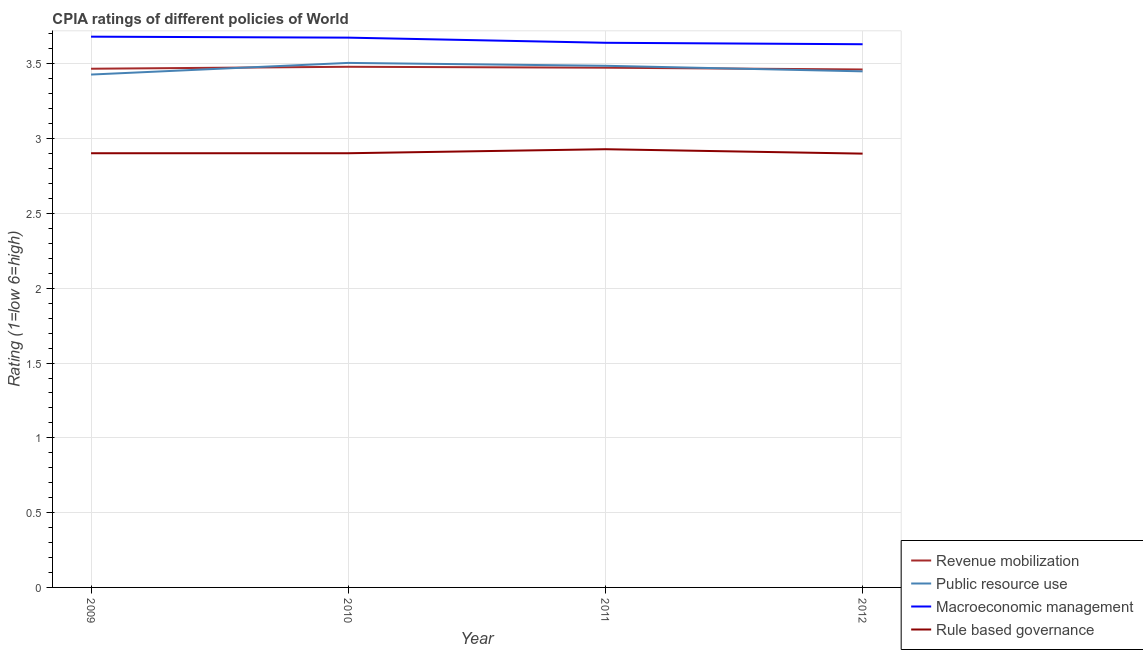How many different coloured lines are there?
Ensure brevity in your answer.  4. Does the line corresponding to cpia rating of rule based governance intersect with the line corresponding to cpia rating of macroeconomic management?
Provide a short and direct response. No. What is the cpia rating of revenue mobilization in 2009?
Your answer should be very brief. 3.47. Across all years, what is the maximum cpia rating of public resource use?
Provide a succinct answer. 3.51. Across all years, what is the minimum cpia rating of rule based governance?
Ensure brevity in your answer.  2.9. In which year was the cpia rating of revenue mobilization maximum?
Provide a succinct answer. 2010. In which year was the cpia rating of public resource use minimum?
Offer a terse response. 2009. What is the total cpia rating of macroeconomic management in the graph?
Offer a very short reply. 14.63. What is the difference between the cpia rating of public resource use in 2009 and that in 2010?
Your answer should be very brief. -0.08. What is the difference between the cpia rating of public resource use in 2011 and the cpia rating of macroeconomic management in 2012?
Your response must be concise. -0.14. What is the average cpia rating of public resource use per year?
Provide a short and direct response. 3.47. In the year 2009, what is the difference between the cpia rating of macroeconomic management and cpia rating of public resource use?
Keep it short and to the point. 0.25. What is the ratio of the cpia rating of macroeconomic management in 2009 to that in 2011?
Make the answer very short. 1.01. Is the difference between the cpia rating of macroeconomic management in 2010 and 2012 greater than the difference between the cpia rating of public resource use in 2010 and 2012?
Your answer should be compact. No. What is the difference between the highest and the second highest cpia rating of rule based governance?
Give a very brief answer. 0.03. What is the difference between the highest and the lowest cpia rating of revenue mobilization?
Provide a succinct answer. 0.02. In how many years, is the cpia rating of rule based governance greater than the average cpia rating of rule based governance taken over all years?
Provide a short and direct response. 1. Is the sum of the cpia rating of macroeconomic management in 2009 and 2012 greater than the maximum cpia rating of rule based governance across all years?
Give a very brief answer. Yes. Is it the case that in every year, the sum of the cpia rating of macroeconomic management and cpia rating of rule based governance is greater than the sum of cpia rating of revenue mobilization and cpia rating of public resource use?
Your answer should be compact. No. Does the cpia rating of public resource use monotonically increase over the years?
Your answer should be compact. No. Are the values on the major ticks of Y-axis written in scientific E-notation?
Your answer should be very brief. No. Does the graph contain any zero values?
Your answer should be compact. No. Where does the legend appear in the graph?
Offer a very short reply. Bottom right. How are the legend labels stacked?
Make the answer very short. Vertical. What is the title of the graph?
Give a very brief answer. CPIA ratings of different policies of World. What is the label or title of the X-axis?
Your answer should be compact. Year. What is the label or title of the Y-axis?
Your answer should be very brief. Rating (1=low 6=high). What is the Rating (1=low 6=high) of Revenue mobilization in 2009?
Give a very brief answer. 3.47. What is the Rating (1=low 6=high) of Public resource use in 2009?
Ensure brevity in your answer.  3.43. What is the Rating (1=low 6=high) of Macroeconomic management in 2009?
Your answer should be very brief. 3.68. What is the Rating (1=low 6=high) of Rule based governance in 2009?
Your answer should be very brief. 2.9. What is the Rating (1=low 6=high) of Revenue mobilization in 2010?
Keep it short and to the point. 3.48. What is the Rating (1=low 6=high) in Public resource use in 2010?
Offer a very short reply. 3.51. What is the Rating (1=low 6=high) of Macroeconomic management in 2010?
Offer a very short reply. 3.68. What is the Rating (1=low 6=high) of Rule based governance in 2010?
Make the answer very short. 2.9. What is the Rating (1=low 6=high) in Revenue mobilization in 2011?
Offer a very short reply. 3.47. What is the Rating (1=low 6=high) of Public resource use in 2011?
Provide a short and direct response. 3.49. What is the Rating (1=low 6=high) of Macroeconomic management in 2011?
Give a very brief answer. 3.64. What is the Rating (1=low 6=high) in Rule based governance in 2011?
Keep it short and to the point. 2.93. What is the Rating (1=low 6=high) of Revenue mobilization in 2012?
Ensure brevity in your answer.  3.46. What is the Rating (1=low 6=high) in Public resource use in 2012?
Offer a terse response. 3.45. What is the Rating (1=low 6=high) of Macroeconomic management in 2012?
Your answer should be compact. 3.63. What is the Rating (1=low 6=high) in Rule based governance in 2012?
Offer a very short reply. 2.9. Across all years, what is the maximum Rating (1=low 6=high) in Revenue mobilization?
Keep it short and to the point. 3.48. Across all years, what is the maximum Rating (1=low 6=high) of Public resource use?
Your answer should be compact. 3.51. Across all years, what is the maximum Rating (1=low 6=high) in Macroeconomic management?
Your answer should be very brief. 3.68. Across all years, what is the maximum Rating (1=low 6=high) of Rule based governance?
Offer a terse response. 2.93. Across all years, what is the minimum Rating (1=low 6=high) of Revenue mobilization?
Give a very brief answer. 3.46. Across all years, what is the minimum Rating (1=low 6=high) of Public resource use?
Offer a terse response. 3.43. Across all years, what is the minimum Rating (1=low 6=high) in Macroeconomic management?
Your answer should be compact. 3.63. What is the total Rating (1=low 6=high) in Revenue mobilization in the graph?
Give a very brief answer. 13.88. What is the total Rating (1=low 6=high) in Public resource use in the graph?
Keep it short and to the point. 13.87. What is the total Rating (1=low 6=high) in Macroeconomic management in the graph?
Your answer should be very brief. 14.63. What is the total Rating (1=low 6=high) of Rule based governance in the graph?
Ensure brevity in your answer.  11.63. What is the difference between the Rating (1=low 6=high) of Revenue mobilization in 2009 and that in 2010?
Provide a succinct answer. -0.01. What is the difference between the Rating (1=low 6=high) of Public resource use in 2009 and that in 2010?
Your answer should be compact. -0.08. What is the difference between the Rating (1=low 6=high) in Macroeconomic management in 2009 and that in 2010?
Provide a succinct answer. 0.01. What is the difference between the Rating (1=low 6=high) of Rule based governance in 2009 and that in 2010?
Provide a short and direct response. 0. What is the difference between the Rating (1=low 6=high) in Revenue mobilization in 2009 and that in 2011?
Ensure brevity in your answer.  -0.01. What is the difference between the Rating (1=low 6=high) of Public resource use in 2009 and that in 2011?
Give a very brief answer. -0.06. What is the difference between the Rating (1=low 6=high) of Macroeconomic management in 2009 and that in 2011?
Offer a very short reply. 0.04. What is the difference between the Rating (1=low 6=high) in Rule based governance in 2009 and that in 2011?
Offer a very short reply. -0.03. What is the difference between the Rating (1=low 6=high) in Revenue mobilization in 2009 and that in 2012?
Give a very brief answer. 0.01. What is the difference between the Rating (1=low 6=high) in Public resource use in 2009 and that in 2012?
Make the answer very short. -0.02. What is the difference between the Rating (1=low 6=high) of Macroeconomic management in 2009 and that in 2012?
Provide a short and direct response. 0.05. What is the difference between the Rating (1=low 6=high) of Rule based governance in 2009 and that in 2012?
Provide a succinct answer. 0. What is the difference between the Rating (1=low 6=high) in Revenue mobilization in 2010 and that in 2011?
Provide a short and direct response. 0.01. What is the difference between the Rating (1=low 6=high) of Public resource use in 2010 and that in 2011?
Provide a succinct answer. 0.02. What is the difference between the Rating (1=low 6=high) in Macroeconomic management in 2010 and that in 2011?
Your answer should be very brief. 0.03. What is the difference between the Rating (1=low 6=high) of Rule based governance in 2010 and that in 2011?
Give a very brief answer. -0.03. What is the difference between the Rating (1=low 6=high) of Revenue mobilization in 2010 and that in 2012?
Your answer should be very brief. 0.02. What is the difference between the Rating (1=low 6=high) in Public resource use in 2010 and that in 2012?
Your response must be concise. 0.06. What is the difference between the Rating (1=low 6=high) of Macroeconomic management in 2010 and that in 2012?
Offer a very short reply. 0.04. What is the difference between the Rating (1=low 6=high) of Rule based governance in 2010 and that in 2012?
Your answer should be very brief. 0. What is the difference between the Rating (1=low 6=high) in Revenue mobilization in 2011 and that in 2012?
Keep it short and to the point. 0.01. What is the difference between the Rating (1=low 6=high) in Public resource use in 2011 and that in 2012?
Keep it short and to the point. 0.04. What is the difference between the Rating (1=low 6=high) of Macroeconomic management in 2011 and that in 2012?
Provide a succinct answer. 0.01. What is the difference between the Rating (1=low 6=high) in Rule based governance in 2011 and that in 2012?
Ensure brevity in your answer.  0.03. What is the difference between the Rating (1=low 6=high) in Revenue mobilization in 2009 and the Rating (1=low 6=high) in Public resource use in 2010?
Your answer should be very brief. -0.04. What is the difference between the Rating (1=low 6=high) in Revenue mobilization in 2009 and the Rating (1=low 6=high) in Macroeconomic management in 2010?
Give a very brief answer. -0.21. What is the difference between the Rating (1=low 6=high) in Revenue mobilization in 2009 and the Rating (1=low 6=high) in Rule based governance in 2010?
Make the answer very short. 0.56. What is the difference between the Rating (1=low 6=high) of Public resource use in 2009 and the Rating (1=low 6=high) of Macroeconomic management in 2010?
Your answer should be compact. -0.25. What is the difference between the Rating (1=low 6=high) of Public resource use in 2009 and the Rating (1=low 6=high) of Rule based governance in 2010?
Offer a terse response. 0.53. What is the difference between the Rating (1=low 6=high) in Macroeconomic management in 2009 and the Rating (1=low 6=high) in Rule based governance in 2010?
Provide a succinct answer. 0.78. What is the difference between the Rating (1=low 6=high) of Revenue mobilization in 2009 and the Rating (1=low 6=high) of Public resource use in 2011?
Offer a terse response. -0.02. What is the difference between the Rating (1=low 6=high) in Revenue mobilization in 2009 and the Rating (1=low 6=high) in Macroeconomic management in 2011?
Offer a terse response. -0.17. What is the difference between the Rating (1=low 6=high) in Revenue mobilization in 2009 and the Rating (1=low 6=high) in Rule based governance in 2011?
Offer a terse response. 0.54. What is the difference between the Rating (1=low 6=high) in Public resource use in 2009 and the Rating (1=low 6=high) in Macroeconomic management in 2011?
Ensure brevity in your answer.  -0.21. What is the difference between the Rating (1=low 6=high) in Public resource use in 2009 and the Rating (1=low 6=high) in Rule based governance in 2011?
Your answer should be compact. 0.5. What is the difference between the Rating (1=low 6=high) of Macroeconomic management in 2009 and the Rating (1=low 6=high) of Rule based governance in 2011?
Make the answer very short. 0.75. What is the difference between the Rating (1=low 6=high) in Revenue mobilization in 2009 and the Rating (1=low 6=high) in Public resource use in 2012?
Offer a very short reply. 0.02. What is the difference between the Rating (1=low 6=high) in Revenue mobilization in 2009 and the Rating (1=low 6=high) in Macroeconomic management in 2012?
Provide a short and direct response. -0.16. What is the difference between the Rating (1=low 6=high) in Revenue mobilization in 2009 and the Rating (1=low 6=high) in Rule based governance in 2012?
Offer a terse response. 0.57. What is the difference between the Rating (1=low 6=high) in Public resource use in 2009 and the Rating (1=low 6=high) in Macroeconomic management in 2012?
Your answer should be compact. -0.2. What is the difference between the Rating (1=low 6=high) of Public resource use in 2009 and the Rating (1=low 6=high) of Rule based governance in 2012?
Offer a very short reply. 0.53. What is the difference between the Rating (1=low 6=high) of Macroeconomic management in 2009 and the Rating (1=low 6=high) of Rule based governance in 2012?
Your answer should be very brief. 0.78. What is the difference between the Rating (1=low 6=high) in Revenue mobilization in 2010 and the Rating (1=low 6=high) in Public resource use in 2011?
Provide a short and direct response. -0.01. What is the difference between the Rating (1=low 6=high) in Revenue mobilization in 2010 and the Rating (1=low 6=high) in Macroeconomic management in 2011?
Make the answer very short. -0.16. What is the difference between the Rating (1=low 6=high) in Revenue mobilization in 2010 and the Rating (1=low 6=high) in Rule based governance in 2011?
Your response must be concise. 0.55. What is the difference between the Rating (1=low 6=high) in Public resource use in 2010 and the Rating (1=low 6=high) in Macroeconomic management in 2011?
Make the answer very short. -0.13. What is the difference between the Rating (1=low 6=high) of Public resource use in 2010 and the Rating (1=low 6=high) of Rule based governance in 2011?
Provide a short and direct response. 0.58. What is the difference between the Rating (1=low 6=high) of Macroeconomic management in 2010 and the Rating (1=low 6=high) of Rule based governance in 2011?
Make the answer very short. 0.75. What is the difference between the Rating (1=low 6=high) in Revenue mobilization in 2010 and the Rating (1=low 6=high) in Public resource use in 2012?
Keep it short and to the point. 0.03. What is the difference between the Rating (1=low 6=high) of Revenue mobilization in 2010 and the Rating (1=low 6=high) of Macroeconomic management in 2012?
Ensure brevity in your answer.  -0.15. What is the difference between the Rating (1=low 6=high) of Revenue mobilization in 2010 and the Rating (1=low 6=high) of Rule based governance in 2012?
Offer a terse response. 0.58. What is the difference between the Rating (1=low 6=high) of Public resource use in 2010 and the Rating (1=low 6=high) of Macroeconomic management in 2012?
Offer a very short reply. -0.12. What is the difference between the Rating (1=low 6=high) of Public resource use in 2010 and the Rating (1=low 6=high) of Rule based governance in 2012?
Offer a terse response. 0.61. What is the difference between the Rating (1=low 6=high) in Macroeconomic management in 2010 and the Rating (1=low 6=high) in Rule based governance in 2012?
Offer a terse response. 0.78. What is the difference between the Rating (1=low 6=high) of Revenue mobilization in 2011 and the Rating (1=low 6=high) of Public resource use in 2012?
Ensure brevity in your answer.  0.02. What is the difference between the Rating (1=low 6=high) of Revenue mobilization in 2011 and the Rating (1=low 6=high) of Macroeconomic management in 2012?
Your answer should be compact. -0.16. What is the difference between the Rating (1=low 6=high) in Revenue mobilization in 2011 and the Rating (1=low 6=high) in Rule based governance in 2012?
Keep it short and to the point. 0.57. What is the difference between the Rating (1=low 6=high) of Public resource use in 2011 and the Rating (1=low 6=high) of Macroeconomic management in 2012?
Make the answer very short. -0.14. What is the difference between the Rating (1=low 6=high) in Public resource use in 2011 and the Rating (1=low 6=high) in Rule based governance in 2012?
Your response must be concise. 0.59. What is the difference between the Rating (1=low 6=high) of Macroeconomic management in 2011 and the Rating (1=low 6=high) of Rule based governance in 2012?
Your answer should be very brief. 0.74. What is the average Rating (1=low 6=high) in Revenue mobilization per year?
Your response must be concise. 3.47. What is the average Rating (1=low 6=high) of Public resource use per year?
Ensure brevity in your answer.  3.47. What is the average Rating (1=low 6=high) of Macroeconomic management per year?
Make the answer very short. 3.66. What is the average Rating (1=low 6=high) of Rule based governance per year?
Provide a short and direct response. 2.91. In the year 2009, what is the difference between the Rating (1=low 6=high) of Revenue mobilization and Rating (1=low 6=high) of Public resource use?
Offer a very short reply. 0.04. In the year 2009, what is the difference between the Rating (1=low 6=high) in Revenue mobilization and Rating (1=low 6=high) in Macroeconomic management?
Give a very brief answer. -0.21. In the year 2009, what is the difference between the Rating (1=low 6=high) in Revenue mobilization and Rating (1=low 6=high) in Rule based governance?
Provide a succinct answer. 0.56. In the year 2009, what is the difference between the Rating (1=low 6=high) of Public resource use and Rating (1=low 6=high) of Macroeconomic management?
Provide a succinct answer. -0.25. In the year 2009, what is the difference between the Rating (1=low 6=high) of Public resource use and Rating (1=low 6=high) of Rule based governance?
Offer a very short reply. 0.53. In the year 2009, what is the difference between the Rating (1=low 6=high) in Macroeconomic management and Rating (1=low 6=high) in Rule based governance?
Offer a very short reply. 0.78. In the year 2010, what is the difference between the Rating (1=low 6=high) in Revenue mobilization and Rating (1=low 6=high) in Public resource use?
Provide a succinct answer. -0.03. In the year 2010, what is the difference between the Rating (1=low 6=high) in Revenue mobilization and Rating (1=low 6=high) in Macroeconomic management?
Offer a terse response. -0.19. In the year 2010, what is the difference between the Rating (1=low 6=high) of Revenue mobilization and Rating (1=low 6=high) of Rule based governance?
Your response must be concise. 0.58. In the year 2010, what is the difference between the Rating (1=low 6=high) of Public resource use and Rating (1=low 6=high) of Macroeconomic management?
Keep it short and to the point. -0.17. In the year 2010, what is the difference between the Rating (1=low 6=high) in Public resource use and Rating (1=low 6=high) in Rule based governance?
Provide a succinct answer. 0.6. In the year 2010, what is the difference between the Rating (1=low 6=high) in Macroeconomic management and Rating (1=low 6=high) in Rule based governance?
Make the answer very short. 0.77. In the year 2011, what is the difference between the Rating (1=low 6=high) in Revenue mobilization and Rating (1=low 6=high) in Public resource use?
Your answer should be compact. -0.01. In the year 2011, what is the difference between the Rating (1=low 6=high) of Revenue mobilization and Rating (1=low 6=high) of Rule based governance?
Provide a short and direct response. 0.54. In the year 2011, what is the difference between the Rating (1=low 6=high) in Public resource use and Rating (1=low 6=high) in Macroeconomic management?
Provide a short and direct response. -0.15. In the year 2011, what is the difference between the Rating (1=low 6=high) of Public resource use and Rating (1=low 6=high) of Rule based governance?
Provide a succinct answer. 0.56. In the year 2011, what is the difference between the Rating (1=low 6=high) of Macroeconomic management and Rating (1=low 6=high) of Rule based governance?
Provide a short and direct response. 0.71. In the year 2012, what is the difference between the Rating (1=low 6=high) of Revenue mobilization and Rating (1=low 6=high) of Public resource use?
Give a very brief answer. 0.01. In the year 2012, what is the difference between the Rating (1=low 6=high) of Revenue mobilization and Rating (1=low 6=high) of Macroeconomic management?
Provide a succinct answer. -0.17. In the year 2012, what is the difference between the Rating (1=low 6=high) of Revenue mobilization and Rating (1=low 6=high) of Rule based governance?
Offer a terse response. 0.56. In the year 2012, what is the difference between the Rating (1=low 6=high) of Public resource use and Rating (1=low 6=high) of Macroeconomic management?
Offer a very short reply. -0.18. In the year 2012, what is the difference between the Rating (1=low 6=high) of Public resource use and Rating (1=low 6=high) of Rule based governance?
Offer a very short reply. 0.55. In the year 2012, what is the difference between the Rating (1=low 6=high) of Macroeconomic management and Rating (1=low 6=high) of Rule based governance?
Offer a very short reply. 0.73. What is the ratio of the Rating (1=low 6=high) of Public resource use in 2009 to that in 2010?
Your answer should be compact. 0.98. What is the ratio of the Rating (1=low 6=high) in Macroeconomic management in 2009 to that in 2010?
Provide a succinct answer. 1. What is the ratio of the Rating (1=low 6=high) in Rule based governance in 2009 to that in 2010?
Keep it short and to the point. 1. What is the ratio of the Rating (1=low 6=high) of Revenue mobilization in 2009 to that in 2011?
Keep it short and to the point. 1. What is the ratio of the Rating (1=low 6=high) of Public resource use in 2009 to that in 2011?
Provide a short and direct response. 0.98. What is the ratio of the Rating (1=low 6=high) in Macroeconomic management in 2009 to that in 2011?
Offer a terse response. 1.01. What is the ratio of the Rating (1=low 6=high) in Rule based governance in 2009 to that in 2011?
Give a very brief answer. 0.99. What is the ratio of the Rating (1=low 6=high) in Revenue mobilization in 2009 to that in 2012?
Your answer should be very brief. 1. What is the ratio of the Rating (1=low 6=high) of Macroeconomic management in 2009 to that in 2012?
Give a very brief answer. 1.01. What is the ratio of the Rating (1=low 6=high) in Revenue mobilization in 2010 to that in 2011?
Give a very brief answer. 1. What is the ratio of the Rating (1=low 6=high) of Public resource use in 2010 to that in 2011?
Keep it short and to the point. 1.01. What is the ratio of the Rating (1=low 6=high) of Macroeconomic management in 2010 to that in 2011?
Keep it short and to the point. 1.01. What is the ratio of the Rating (1=low 6=high) in Revenue mobilization in 2010 to that in 2012?
Give a very brief answer. 1.01. What is the ratio of the Rating (1=low 6=high) in Public resource use in 2010 to that in 2012?
Offer a terse response. 1.02. What is the ratio of the Rating (1=low 6=high) in Macroeconomic management in 2010 to that in 2012?
Give a very brief answer. 1.01. What is the ratio of the Rating (1=low 6=high) in Revenue mobilization in 2011 to that in 2012?
Keep it short and to the point. 1. What is the ratio of the Rating (1=low 6=high) in Public resource use in 2011 to that in 2012?
Offer a very short reply. 1.01. What is the ratio of the Rating (1=low 6=high) of Rule based governance in 2011 to that in 2012?
Your answer should be very brief. 1.01. What is the difference between the highest and the second highest Rating (1=low 6=high) of Revenue mobilization?
Keep it short and to the point. 0.01. What is the difference between the highest and the second highest Rating (1=low 6=high) of Public resource use?
Provide a succinct answer. 0.02. What is the difference between the highest and the second highest Rating (1=low 6=high) in Macroeconomic management?
Offer a terse response. 0.01. What is the difference between the highest and the second highest Rating (1=low 6=high) in Rule based governance?
Your response must be concise. 0.03. What is the difference between the highest and the lowest Rating (1=low 6=high) in Revenue mobilization?
Ensure brevity in your answer.  0.02. What is the difference between the highest and the lowest Rating (1=low 6=high) of Public resource use?
Provide a succinct answer. 0.08. What is the difference between the highest and the lowest Rating (1=low 6=high) of Macroeconomic management?
Give a very brief answer. 0.05. What is the difference between the highest and the lowest Rating (1=low 6=high) of Rule based governance?
Provide a succinct answer. 0.03. 